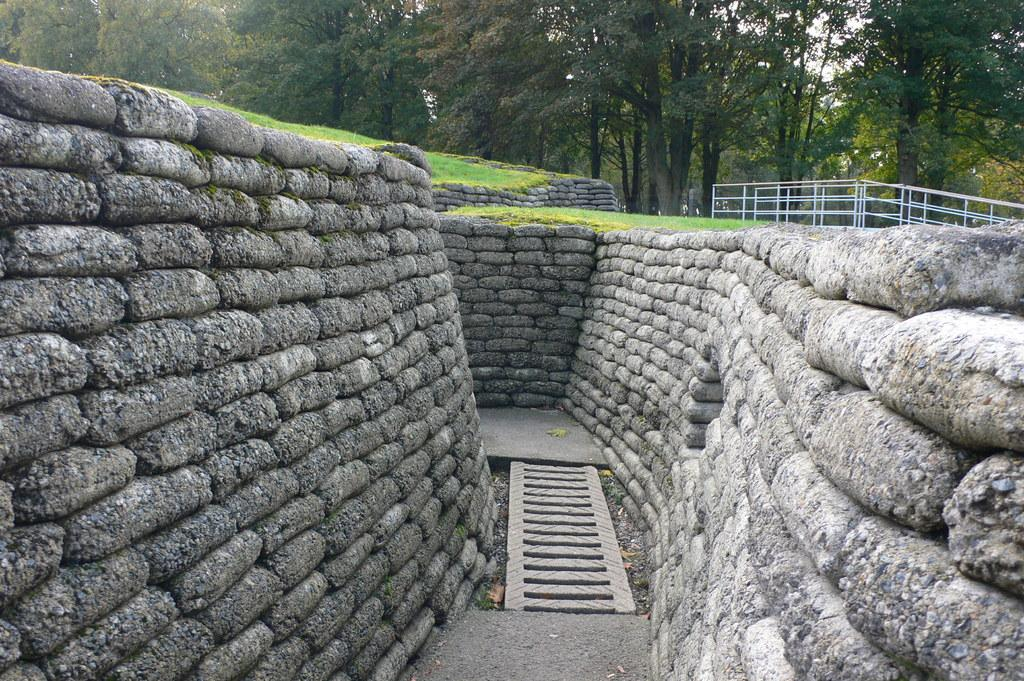What type of natural elements can be seen in the image? There are rocks in the image. What man-made structure is present in the image? There is a fence in the image. What type of vegetation is visible in the background of the image? There is grass and trees in the background of the image. What type of veil is draped over the rocks in the image? There is no veil present in the image; it only features rocks, a fence, grass, and trees. What kind of soup can be seen simmering in the background of the image? There is no soup present in the image; it only features rocks, a fence, trees, and grass. 